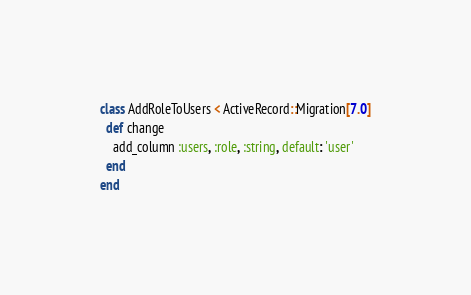<code> <loc_0><loc_0><loc_500><loc_500><_Ruby_>class AddRoleToUsers < ActiveRecord::Migration[7.0]
  def change
    add_column :users, :role, :string, default: 'user'
  end
end
</code> 